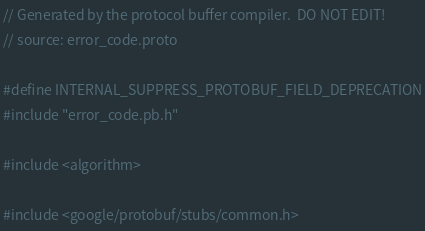Convert code to text. <code><loc_0><loc_0><loc_500><loc_500><_C++_>// Generated by the protocol buffer compiler.  DO NOT EDIT!
// source: error_code.proto

#define INTERNAL_SUPPRESS_PROTOBUF_FIELD_DEPRECATION
#include "error_code.pb.h"

#include <algorithm>

#include <google/protobuf/stubs/common.h></code> 